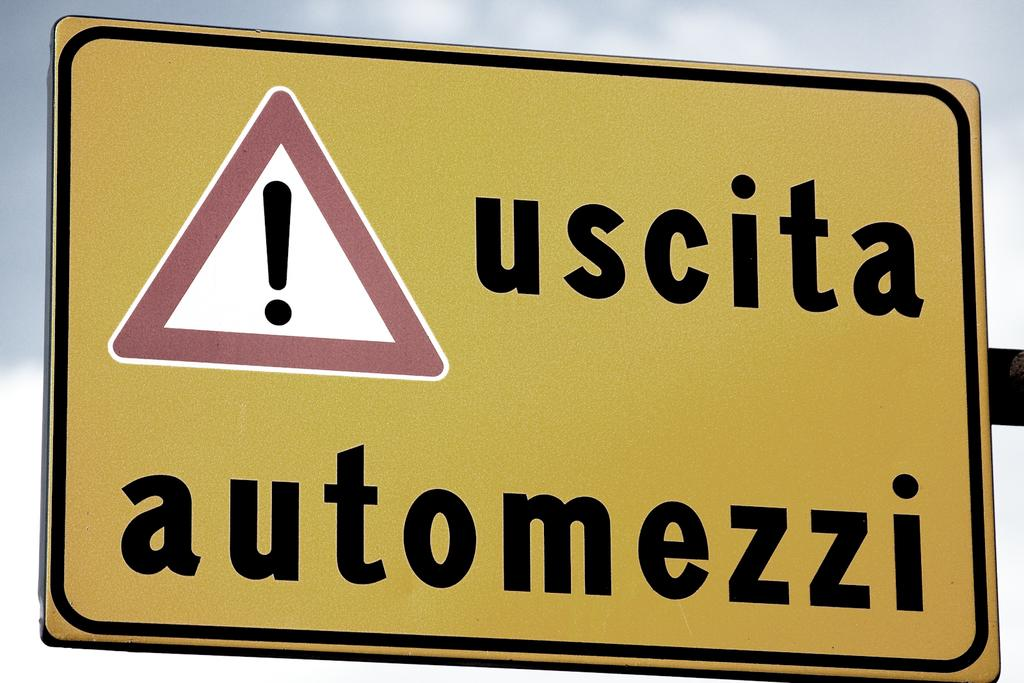<image>
Share a concise interpretation of the image provided. a sign that has the word uscita on it 